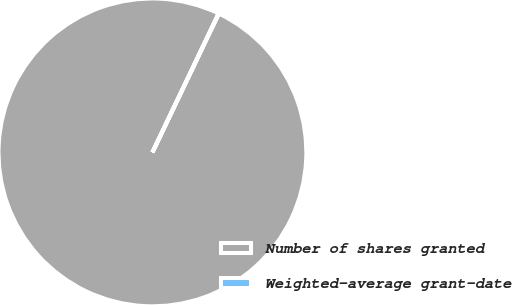<chart> <loc_0><loc_0><loc_500><loc_500><pie_chart><fcel>Number of shares granted<fcel>Weighted-average grant-date<nl><fcel>99.97%<fcel>0.03%<nl></chart> 